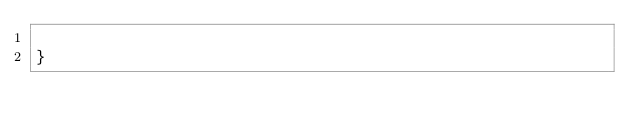Convert code to text. <code><loc_0><loc_0><loc_500><loc_500><_Scala_>
}
</code> 